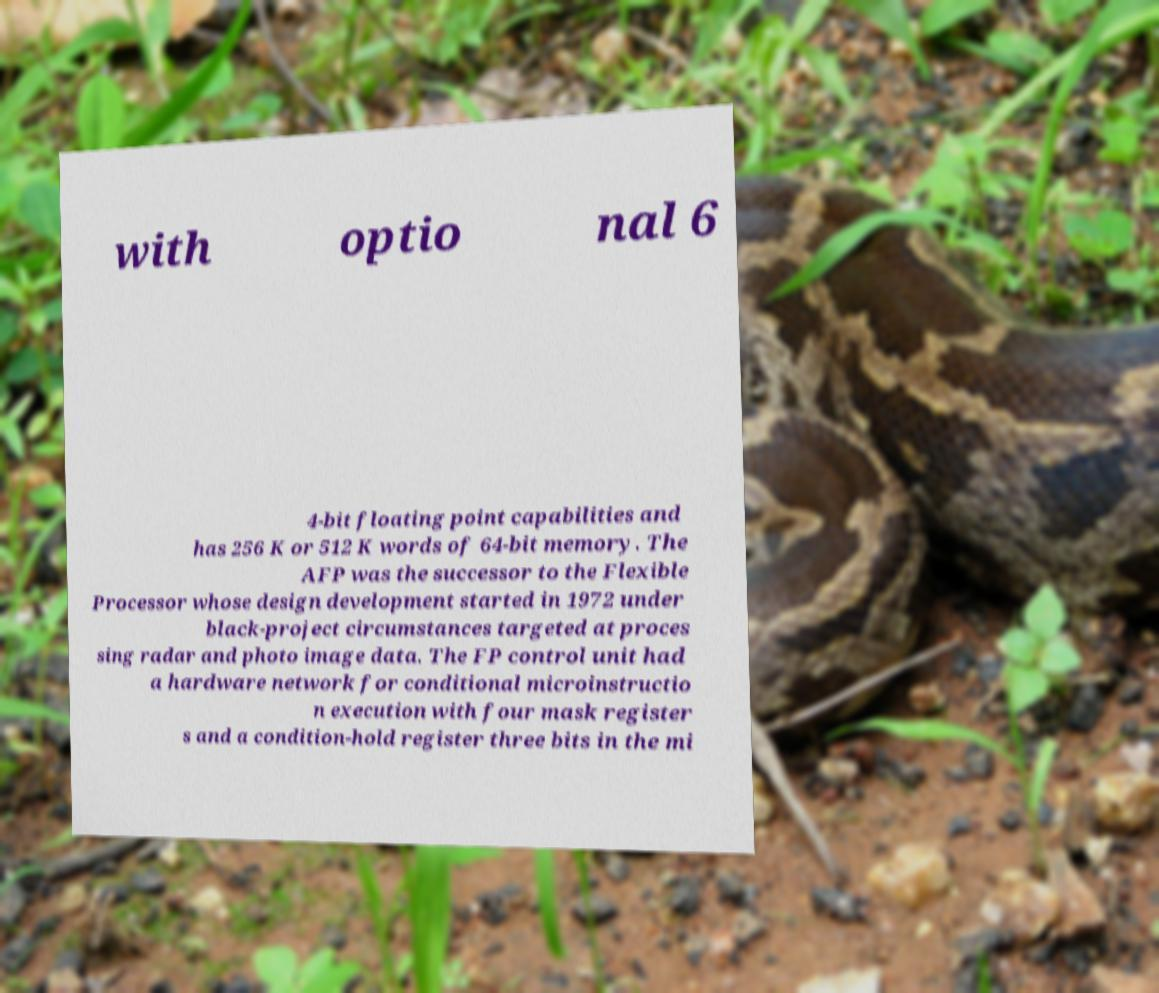There's text embedded in this image that I need extracted. Can you transcribe it verbatim? with optio nal 6 4-bit floating point capabilities and has 256 K or 512 K words of 64-bit memory. The AFP was the successor to the Flexible Processor whose design development started in 1972 under black-project circumstances targeted at proces sing radar and photo image data. The FP control unit had a hardware network for conditional microinstructio n execution with four mask register s and a condition-hold register three bits in the mi 